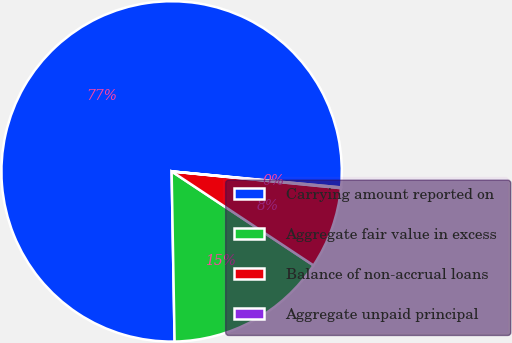Convert chart. <chart><loc_0><loc_0><loc_500><loc_500><pie_chart><fcel>Carrying amount reported on<fcel>Aggregate fair value in excess<fcel>Balance of non-accrual loans<fcel>Aggregate unpaid principal<nl><fcel>76.78%<fcel>15.41%<fcel>7.74%<fcel>0.07%<nl></chart> 